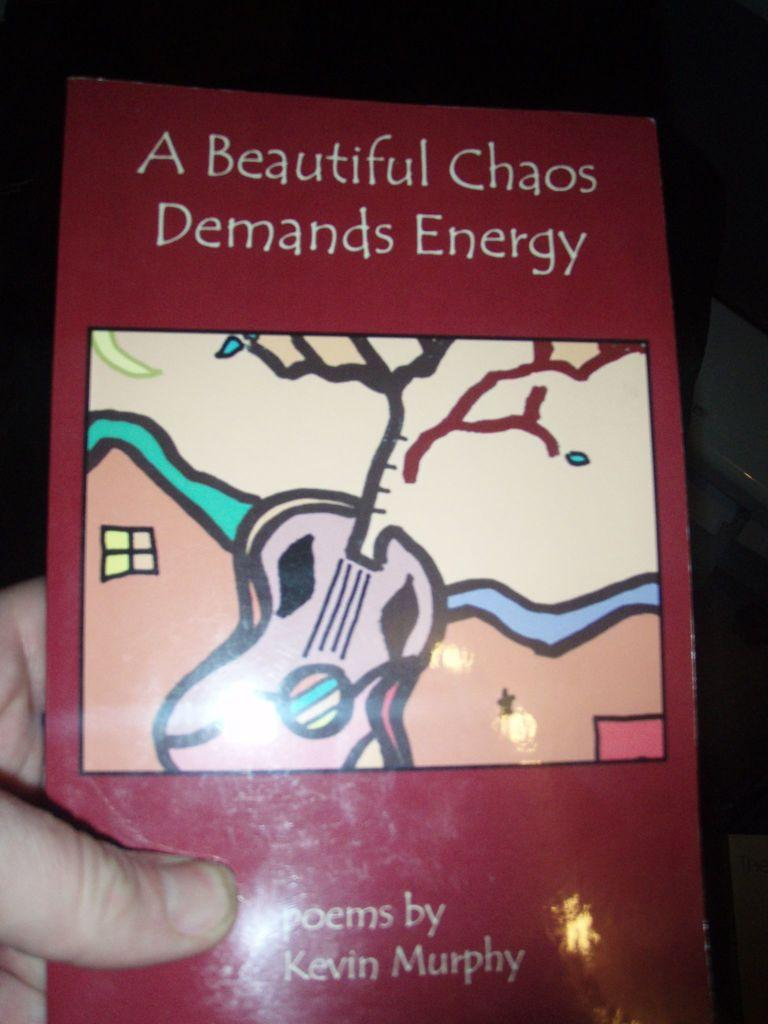What is the person's hand holding in the image? The person's hand is holding an object in the image. Can you describe the color of the object? The object is red in color. What is written on the object? There is writing on the object. Is there any artwork on the object? Yes, there is a drawing on the object. How would you describe the overall appearance of the image? The background of the image is dark. Can you tell me how deep the quicksand is in the image? There is no quicksand present in the image. What type of pen is being used to write on the object? The image does not show a pen or any writing instrument being used. 